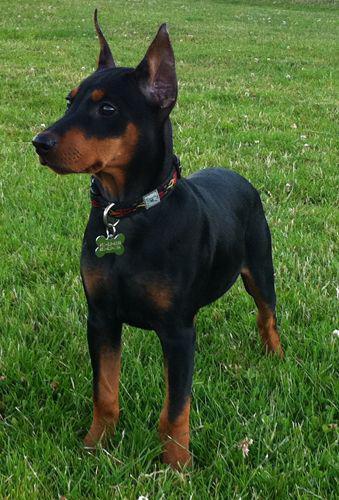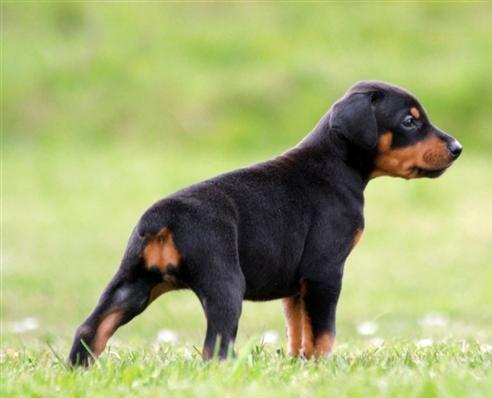The first image is the image on the left, the second image is the image on the right. For the images displayed, is the sentence "A dog is looking towards the right in the right image." factually correct? Answer yes or no. Yes. The first image is the image on the left, the second image is the image on the right. For the images displayed, is the sentence "One of the dogs has uncropped ears." factually correct? Answer yes or no. Yes. 